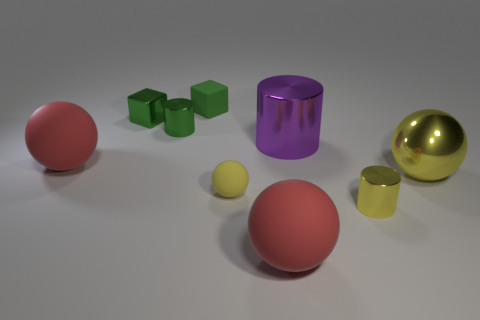Add 1 tiny cubes. How many objects exist? 10 Subtract all cylinders. How many objects are left? 6 Add 1 large gray matte balls. How many large gray matte balls exist? 1 Subtract 2 red balls. How many objects are left? 7 Subtract all green cylinders. Subtract all green cylinders. How many objects are left? 7 Add 9 small yellow metallic cylinders. How many small yellow metallic cylinders are left? 10 